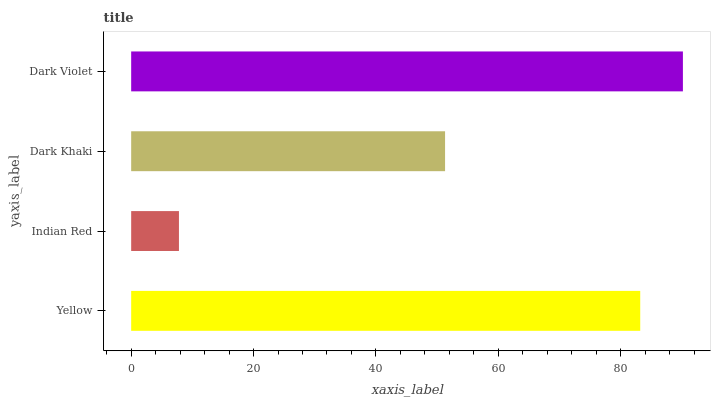Is Indian Red the minimum?
Answer yes or no. Yes. Is Dark Violet the maximum?
Answer yes or no. Yes. Is Dark Khaki the minimum?
Answer yes or no. No. Is Dark Khaki the maximum?
Answer yes or no. No. Is Dark Khaki greater than Indian Red?
Answer yes or no. Yes. Is Indian Red less than Dark Khaki?
Answer yes or no. Yes. Is Indian Red greater than Dark Khaki?
Answer yes or no. No. Is Dark Khaki less than Indian Red?
Answer yes or no. No. Is Yellow the high median?
Answer yes or no. Yes. Is Dark Khaki the low median?
Answer yes or no. Yes. Is Indian Red the high median?
Answer yes or no. No. Is Dark Violet the low median?
Answer yes or no. No. 